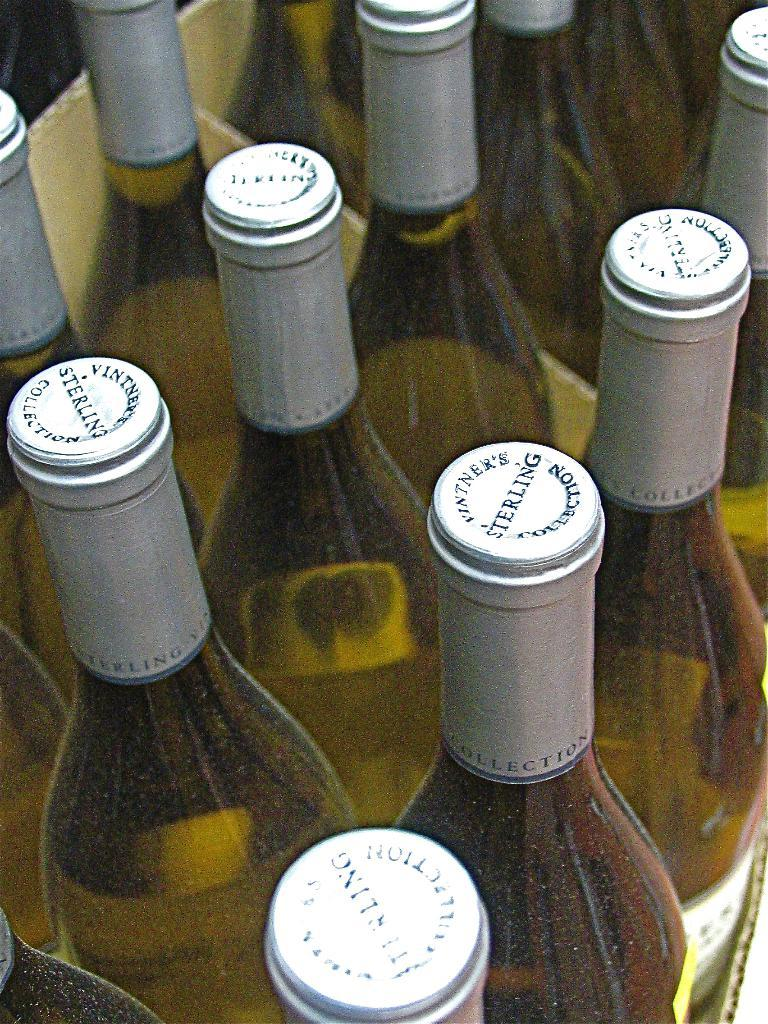<image>
Write a terse but informative summary of the picture. bottles of white wine from Vintner's Sterling collection 